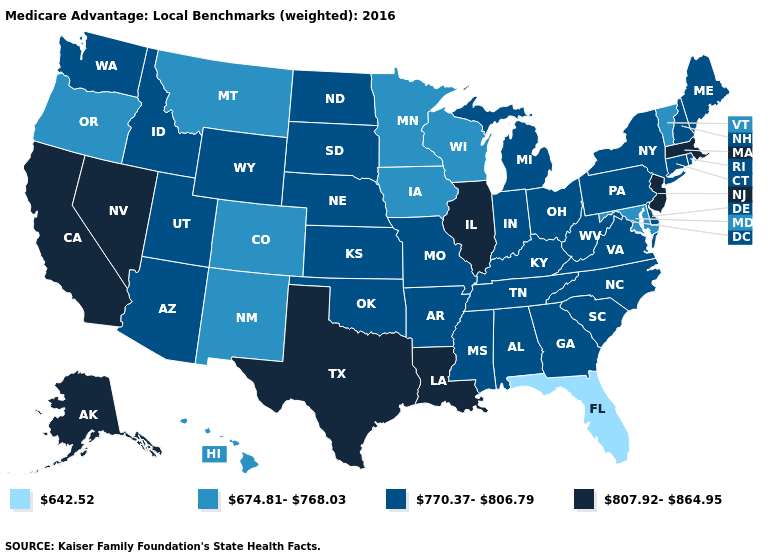Name the states that have a value in the range 674.81-768.03?
Concise answer only. Colorado, Hawaii, Iowa, Maryland, Minnesota, Montana, New Mexico, Oregon, Vermont, Wisconsin. What is the value of Wisconsin?
Concise answer only. 674.81-768.03. Name the states that have a value in the range 807.92-864.95?
Concise answer only. Alaska, California, Illinois, Louisiana, Massachusetts, New Jersey, Nevada, Texas. Name the states that have a value in the range 770.37-806.79?
Short answer required. Alabama, Arkansas, Arizona, Connecticut, Delaware, Georgia, Idaho, Indiana, Kansas, Kentucky, Maine, Michigan, Missouri, Mississippi, North Carolina, North Dakota, Nebraska, New Hampshire, New York, Ohio, Oklahoma, Pennsylvania, Rhode Island, South Carolina, South Dakota, Tennessee, Utah, Virginia, Washington, West Virginia, Wyoming. Name the states that have a value in the range 770.37-806.79?
Be succinct. Alabama, Arkansas, Arizona, Connecticut, Delaware, Georgia, Idaho, Indiana, Kansas, Kentucky, Maine, Michigan, Missouri, Mississippi, North Carolina, North Dakota, Nebraska, New Hampshire, New York, Ohio, Oklahoma, Pennsylvania, Rhode Island, South Carolina, South Dakota, Tennessee, Utah, Virginia, Washington, West Virginia, Wyoming. Among the states that border Wisconsin , which have the lowest value?
Answer briefly. Iowa, Minnesota. Name the states that have a value in the range 642.52?
Short answer required. Florida. What is the highest value in states that border North Carolina?
Give a very brief answer. 770.37-806.79. Which states have the highest value in the USA?
Concise answer only. Alaska, California, Illinois, Louisiana, Massachusetts, New Jersey, Nevada, Texas. What is the value of Hawaii?
Answer briefly. 674.81-768.03. What is the lowest value in the MidWest?
Give a very brief answer. 674.81-768.03. Name the states that have a value in the range 642.52?
Short answer required. Florida. What is the highest value in the USA?
Give a very brief answer. 807.92-864.95. Name the states that have a value in the range 674.81-768.03?
Answer briefly. Colorado, Hawaii, Iowa, Maryland, Minnesota, Montana, New Mexico, Oregon, Vermont, Wisconsin. 